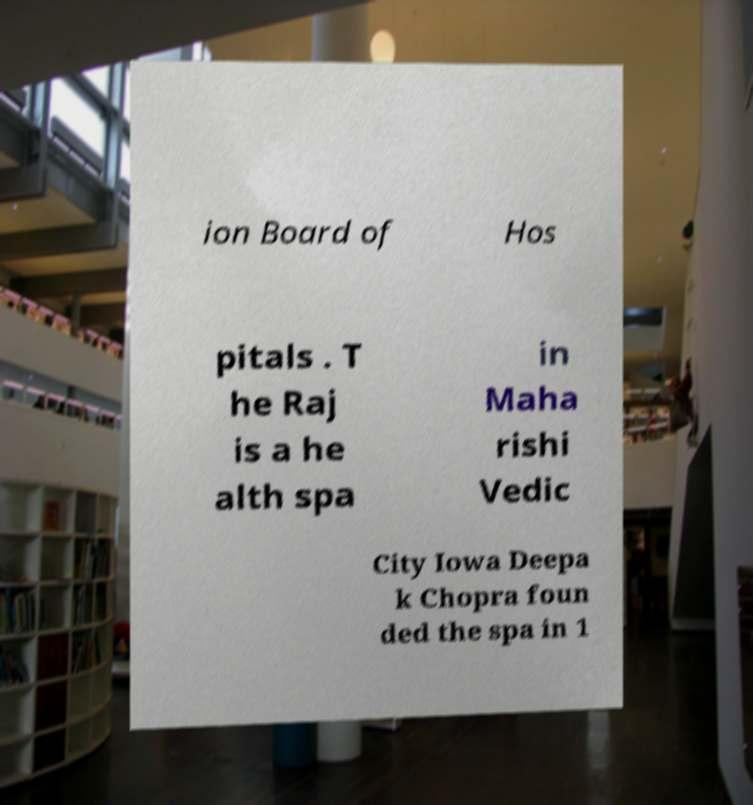Can you read and provide the text displayed in the image?This photo seems to have some interesting text. Can you extract and type it out for me? ion Board of Hos pitals . T he Raj is a he alth spa in Maha rishi Vedic City Iowa Deepa k Chopra foun ded the spa in 1 